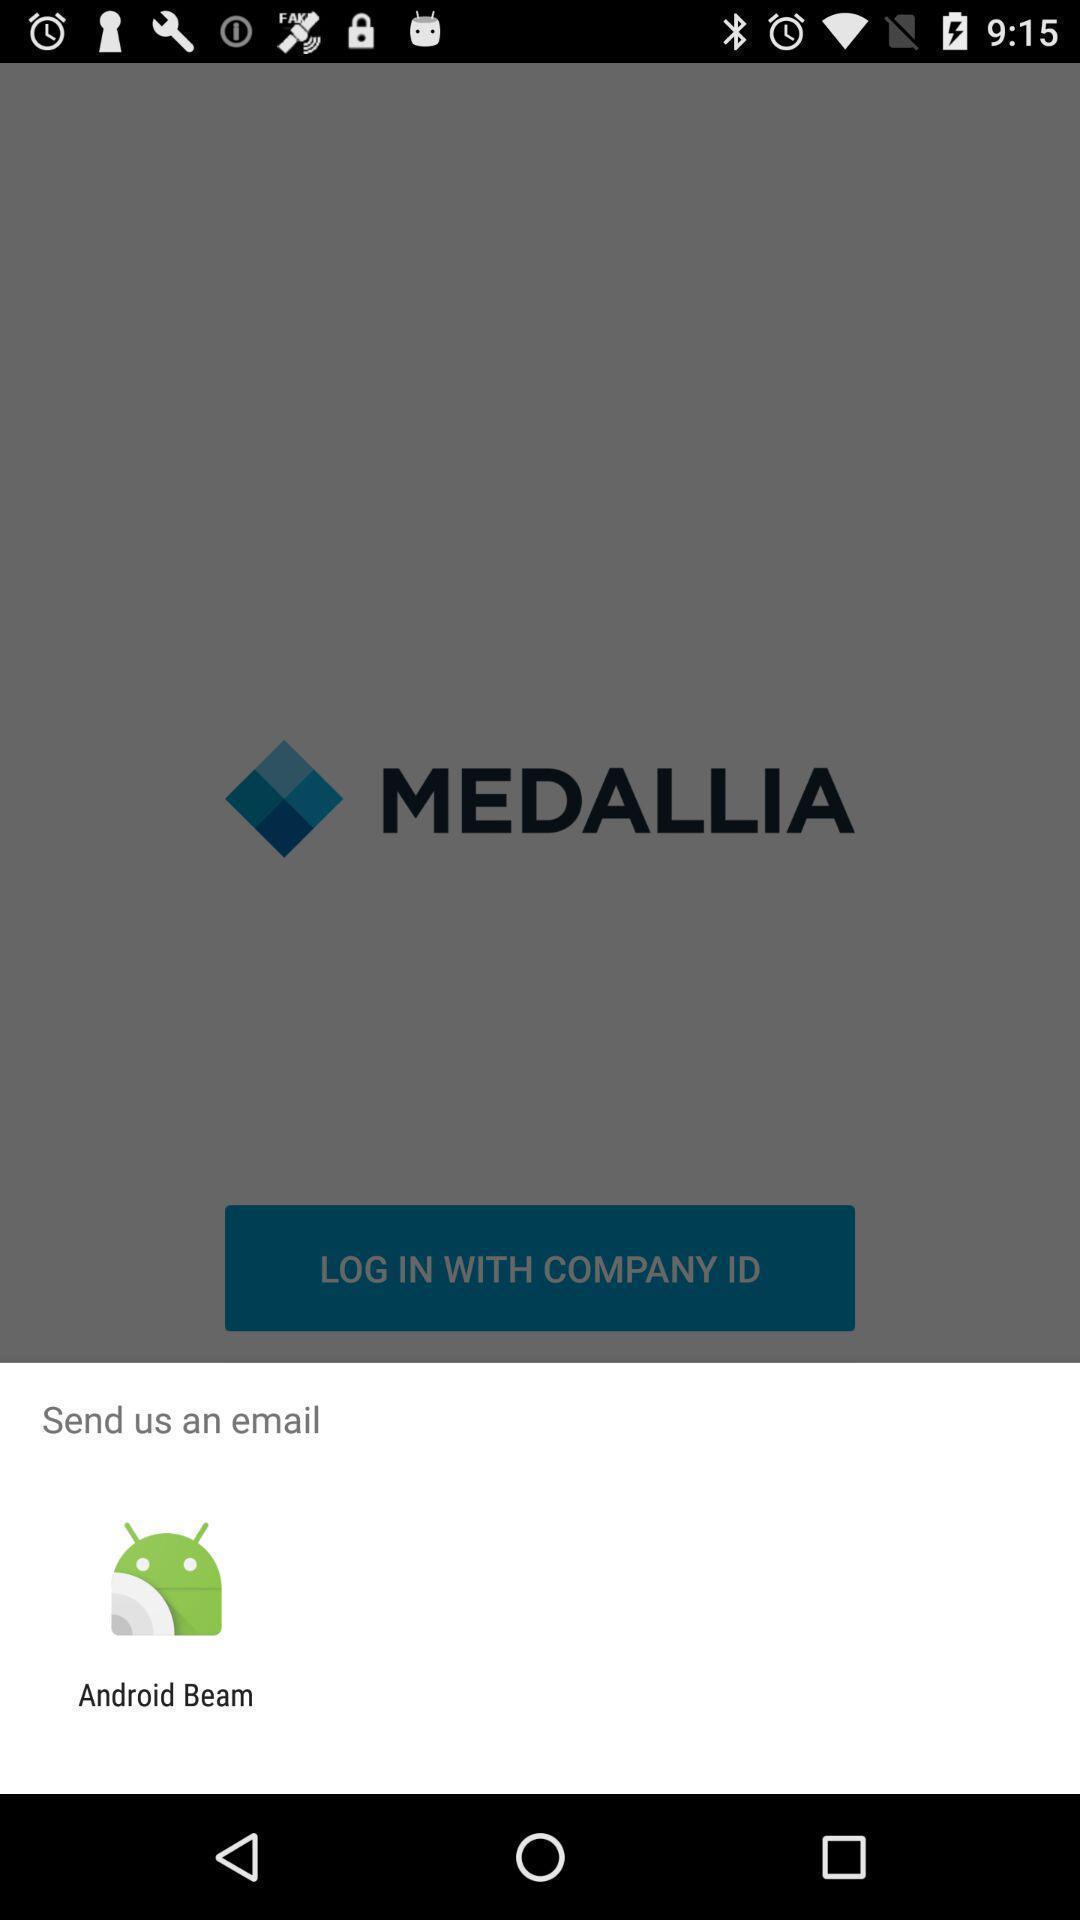Tell me what you see in this picture. Pop up showing send us an email. 